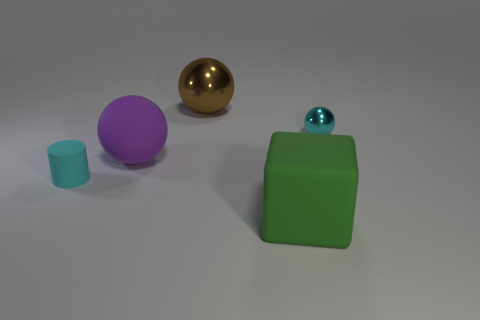Add 2 small cyan rubber things. How many objects exist? 7 Subtract all cyan metal balls. How many balls are left? 2 Subtract all brown balls. How many balls are left? 2 Subtract all blocks. How many objects are left? 4 Subtract 1 cubes. How many cubes are left? 0 Subtract all green spheres. Subtract all green cylinders. How many spheres are left? 3 Subtract all purple cylinders. How many brown spheres are left? 1 Subtract all large rubber spheres. Subtract all large green rubber blocks. How many objects are left? 3 Add 2 large purple balls. How many large purple balls are left? 3 Add 5 cyan objects. How many cyan objects exist? 7 